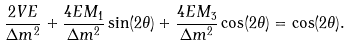<formula> <loc_0><loc_0><loc_500><loc_500>\frac { 2 V E } { \Delta m ^ { 2 } } + \frac { 4 E M _ { 1 } } { \Delta m ^ { 2 } } \sin ( 2 \theta ) + \frac { 4 E M _ { 3 } } { \Delta m ^ { 2 } } \cos ( 2 \theta ) = \cos ( 2 \theta ) .</formula> 